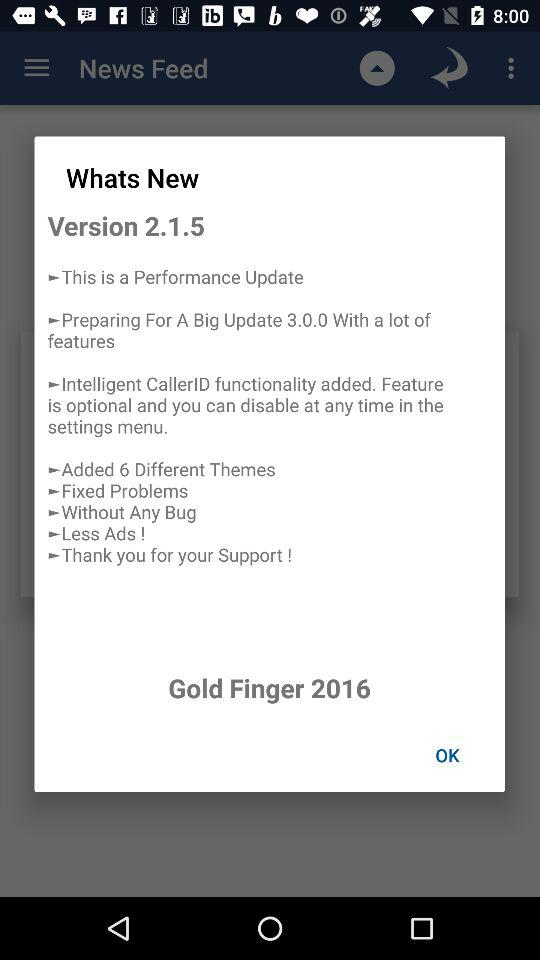How many different themes are added? There are 6 different themes. 